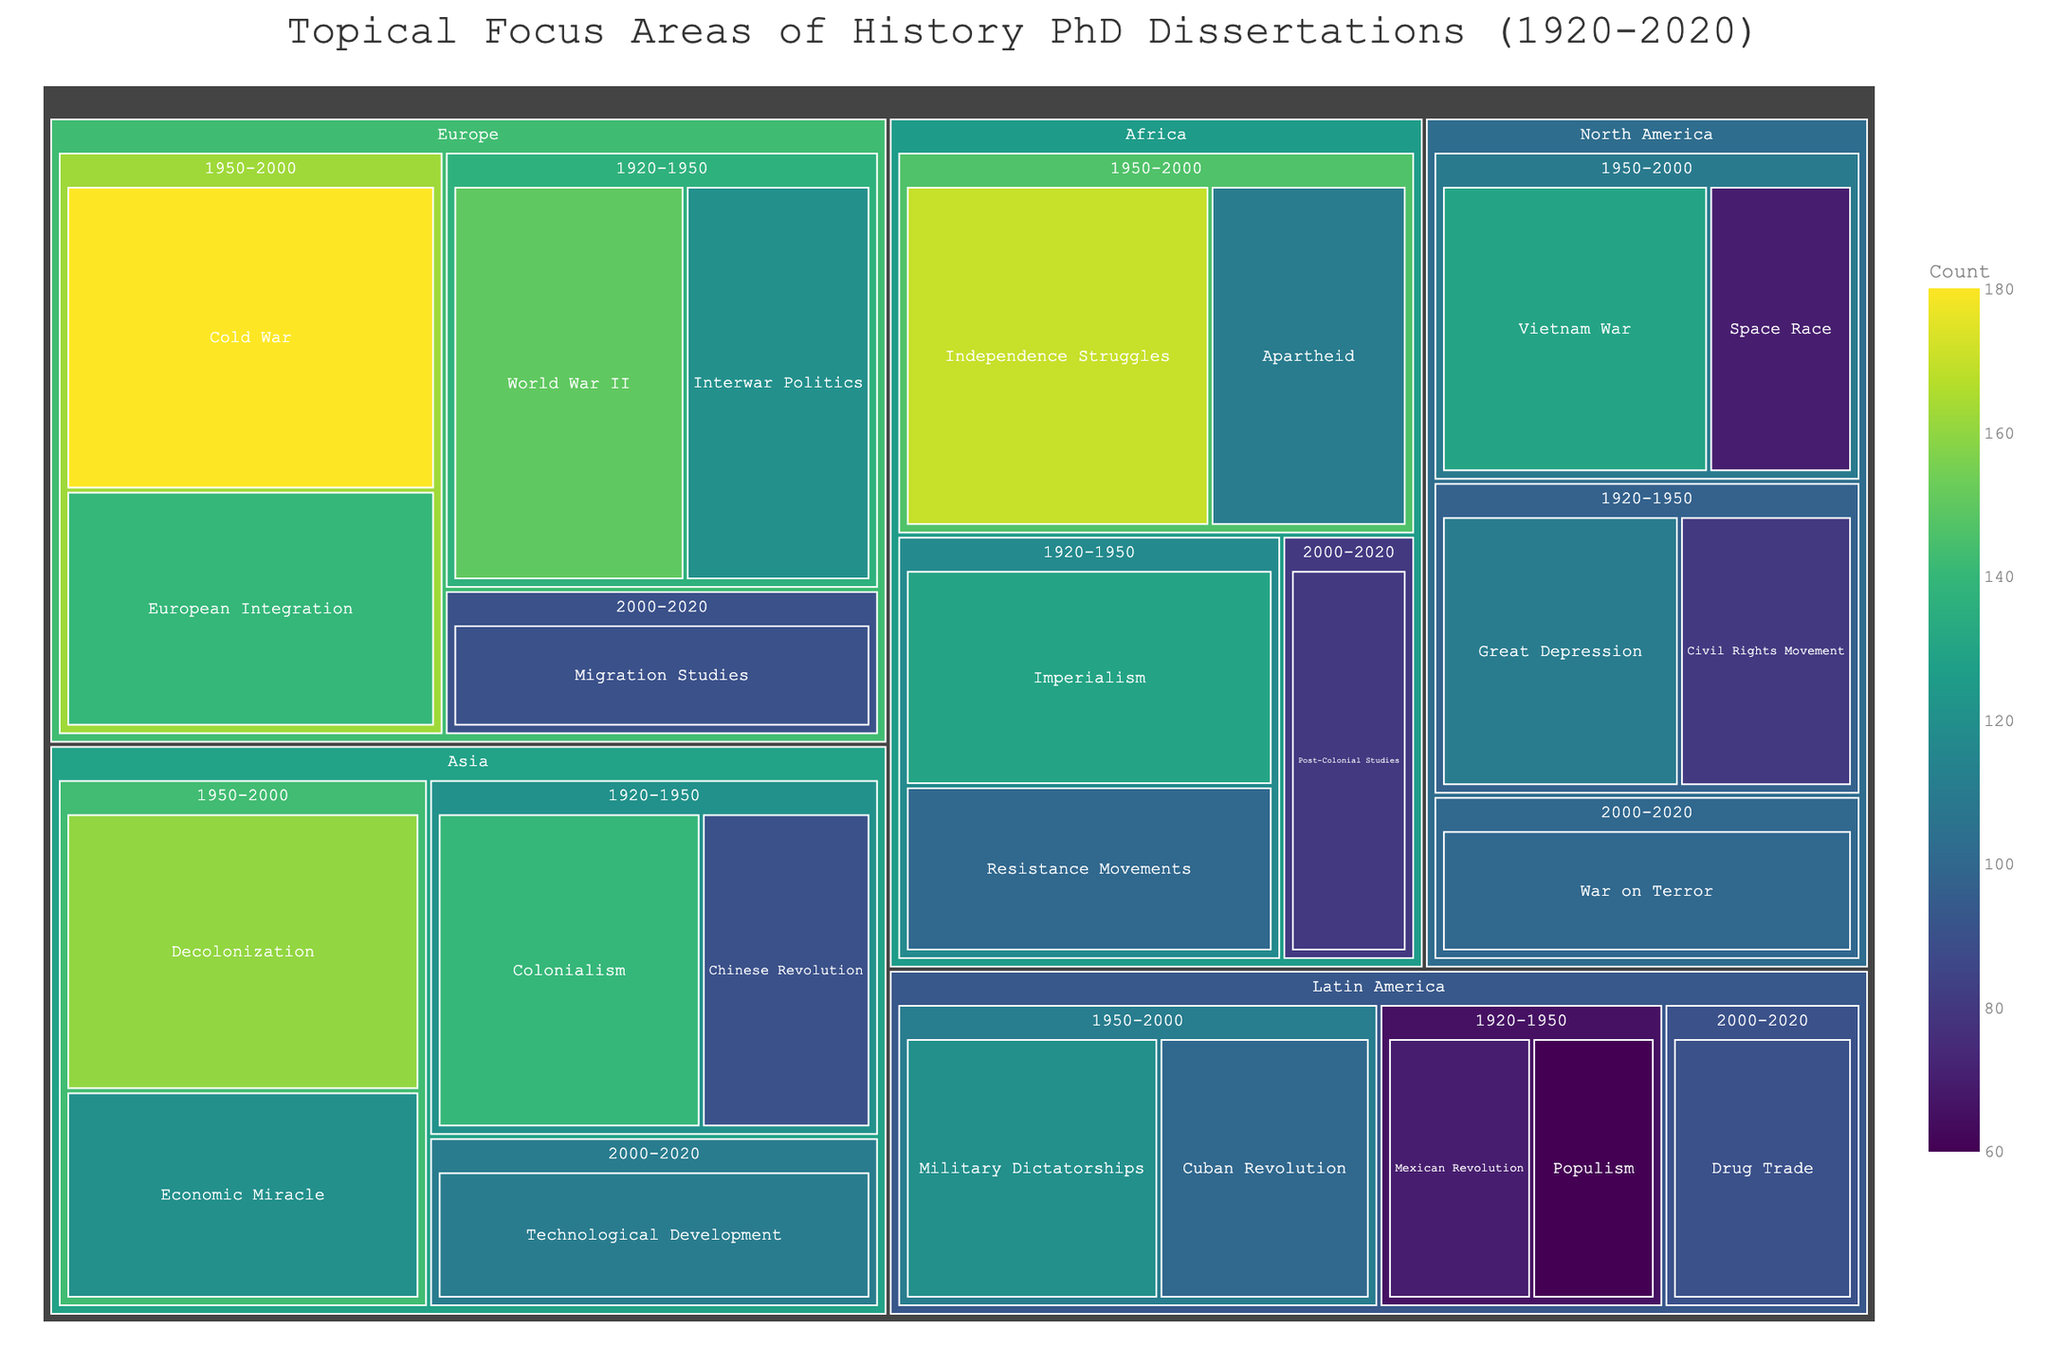What is the title of the treemap? The title is generally located at the top of the figure.
Answer: Topical Focus Areas of History PhD Dissertations (1920-2020) Which region has the highest number of dissertations focused on a single topic within the period 1950-2000? To find the highest count within 1950-2000, look for the topic area with the highest numerical value in this time period across all regions.
Answer: Europe (Cold War with 180 dissertations) What is the total number of dissertations focused on World War II in Europe during 1920-1950 and the War on Terror in North America during 2000-2020? Add the counts for World War II in Europe (150) and War on Terror in North America (100).
Answer: 250 Which time period in Asia has the highest focus on a specific historical topic and which topic is it? Identify the highest count within each time period in Asia and then determine the topic for that time period.
Answer: 1950-2000, Decolonization Compare the number of dissertations on Colonialism in Asia during 1920-1950 to Imperialism in Africa during the same period. Which one has more and by how much? Compare the count for Colonialism in Asia (140) with Imperialism in Africa (130) and subtract to find the difference.
Answer: Colonialism by 10 How many dissertations focused on Migration Studies in Europe during 2000-2020? Locate the count for Migration Studies in Europe for the time period 2000-2020.
Answer: 90 What is the combined count of dissertations focused on Cold War and European Integration in Europe during 1950-2000? Add together the counts for Cold War (180) and European Integration (140).
Answer: 320 Which region has dissertations on the topic of the Cuban Revolution, and in which time period? Check the relevant regions and time periods for the topic area named Cuban Revolution.
Answer: Latin America, 1950-2000 How does the count of dissertations on Drug Trade in Latin America during 2000-2020 compare with those on Technological Development in Asia during the same period? Compare the count for Drug Trade in Latin America (90) to Technological Development in Asia (110).
Answer: Technological Development is higher by 20 What is the lowest count for any topic in North America, and which topic and time period does this correspond to? Identify the topic and time period in North America with the lowest count by comparing the values.
Answer: Space Race during 1950-2000, with a count of 70 